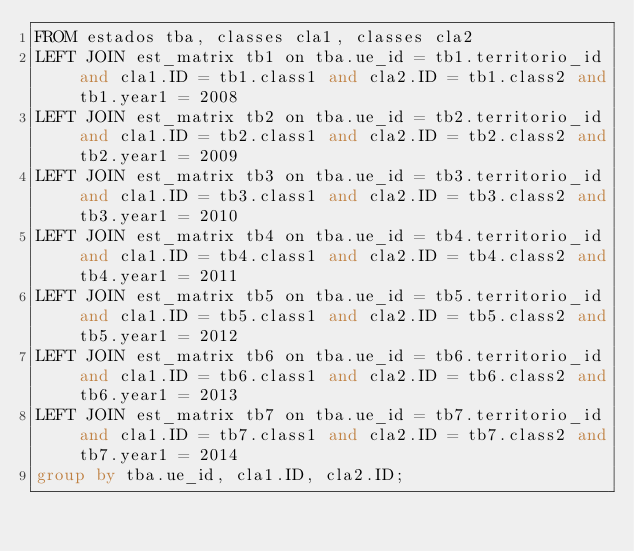<code> <loc_0><loc_0><loc_500><loc_500><_SQL_>FROM estados tba, classes cla1, classes cla2
LEFT JOIN est_matrix tb1 on tba.ue_id = tb1.territorio_id and cla1.ID = tb1.class1 and cla2.ID = tb1.class2 and tb1.year1 = 2008
LEFT JOIN est_matrix tb2 on tba.ue_id = tb2.territorio_id and cla1.ID = tb2.class1 and cla2.ID = tb2.class2 and tb2.year1 = 2009
LEFT JOIN est_matrix tb3 on tba.ue_id = tb3.territorio_id and cla1.ID = tb3.class1 and cla2.ID = tb3.class2 and tb3.year1 = 2010
LEFT JOIN est_matrix tb4 on tba.ue_id = tb4.territorio_id and cla1.ID = tb4.class1 and cla2.ID = tb4.class2 and tb4.year1 = 2011
LEFT JOIN est_matrix tb5 on tba.ue_id = tb5.territorio_id and cla1.ID = tb5.class1 and cla2.ID = tb5.class2 and tb5.year1 = 2012
LEFT JOIN est_matrix tb6 on tba.ue_id = tb6.territorio_id and cla1.ID = tb6.class1 and cla2.ID = tb6.class2 and tb6.year1 = 2013
LEFT JOIN est_matrix tb7 on tba.ue_id = tb7.territorio_id and cla1.ID = tb7.class1 and cla2.ID = tb7.class2 and tb7.year1 = 2014
group by tba.ue_id, cla1.ID, cla2.ID;
</code> 